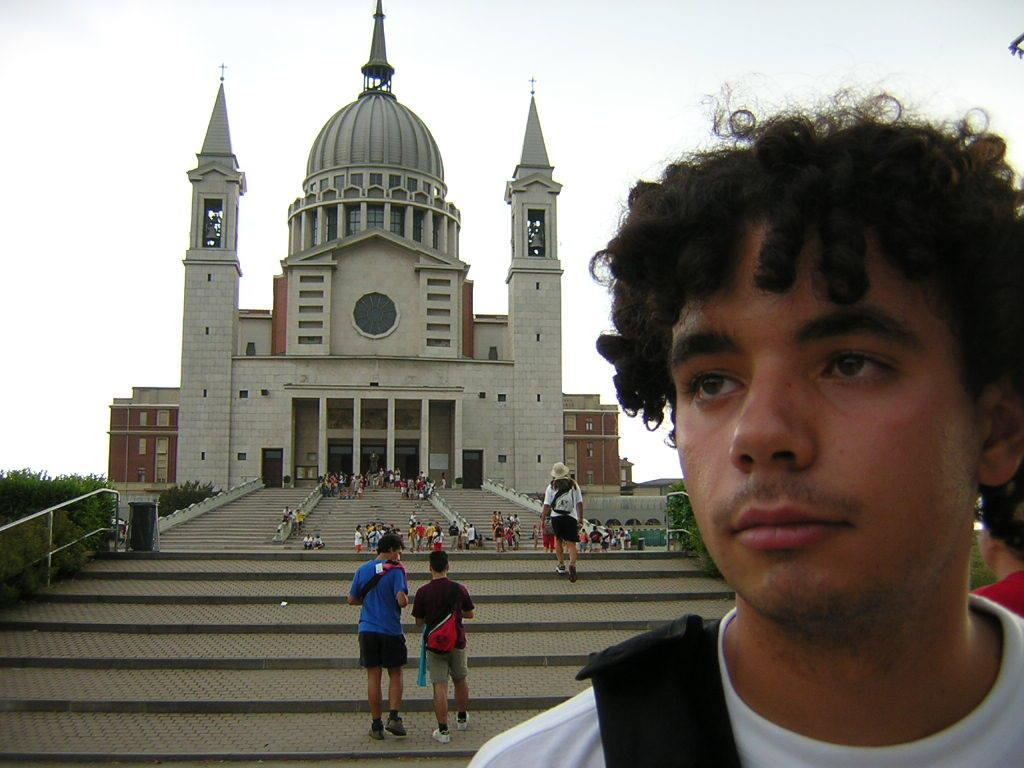What is located on the right side of the image? There is a man on the right side of the image. How many people are the number of people in the image? There are people in the image. What can be seen in the background of the image? There is a church in the background of the image. What type of natural elements are visible in the image? There are plants visible in the image. What part of the natural environment is visible in the image? The sky is visible in the image. What type of comfort can be seen in the image? There is no specific comfort element present in the image; it features a man, people, a church, plants, and the sky. 